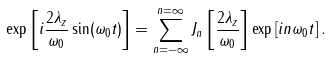<formula> <loc_0><loc_0><loc_500><loc_500>\exp \left [ i \frac { 2 \lambda _ { z } } { \omega _ { 0 } } \sin ( \omega _ { 0 } t ) \right ] = \sum _ { n = - \infty } ^ { n = \infty } J _ { n } \left [ \frac { 2 \lambda _ { z } } { \omega _ { 0 } } \right ] \exp \left [ i n \omega _ { 0 } t \right ] .</formula> 